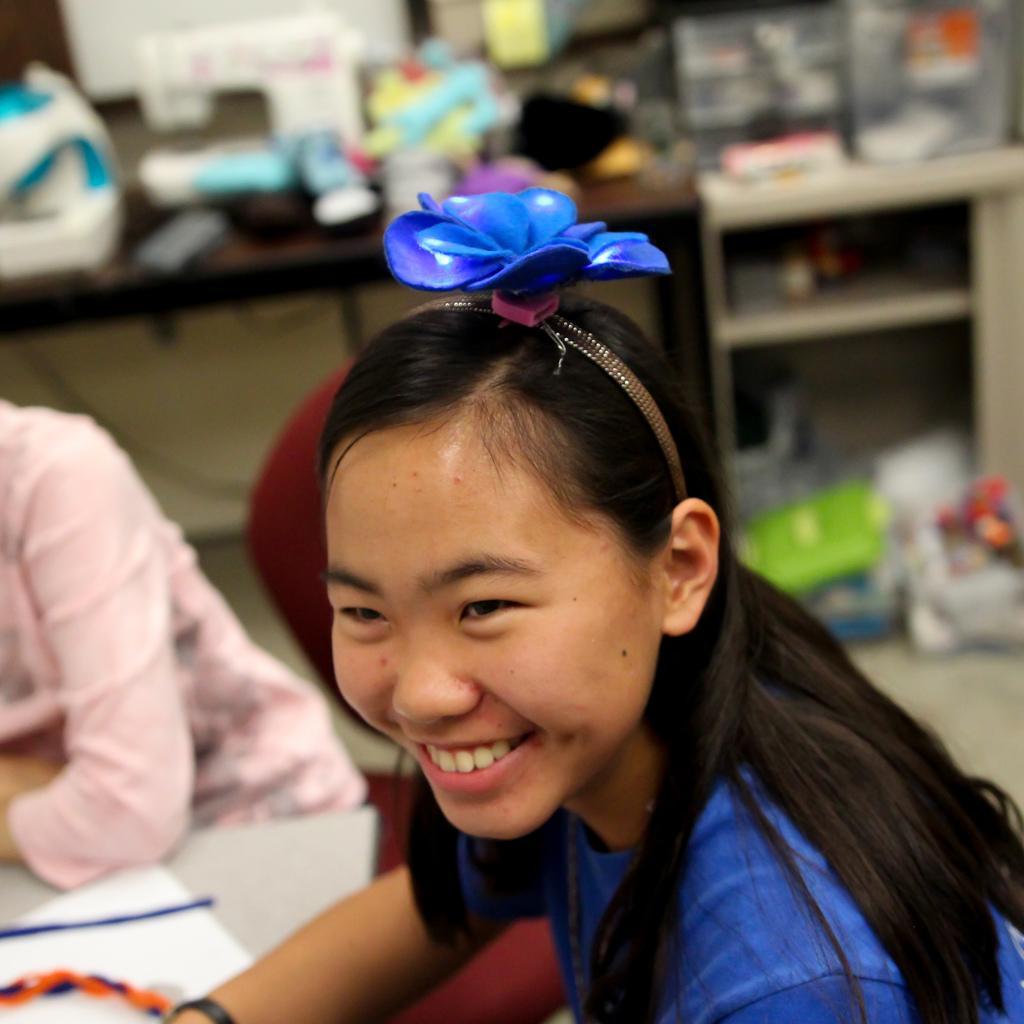Please provide a concise description of this image. The girl in front of the picture is sitting on the chair and she is smiling. Beside her, the girl in pink dress is sitting on the chair. In front of them, we see a white table on which orange color object is placed. In the background, we see a brown table on which some objects are placed. Beside that, we see a cupboard in which some objects are placed. This picture might be clicked inside the room. This picture is blurred in the background. 